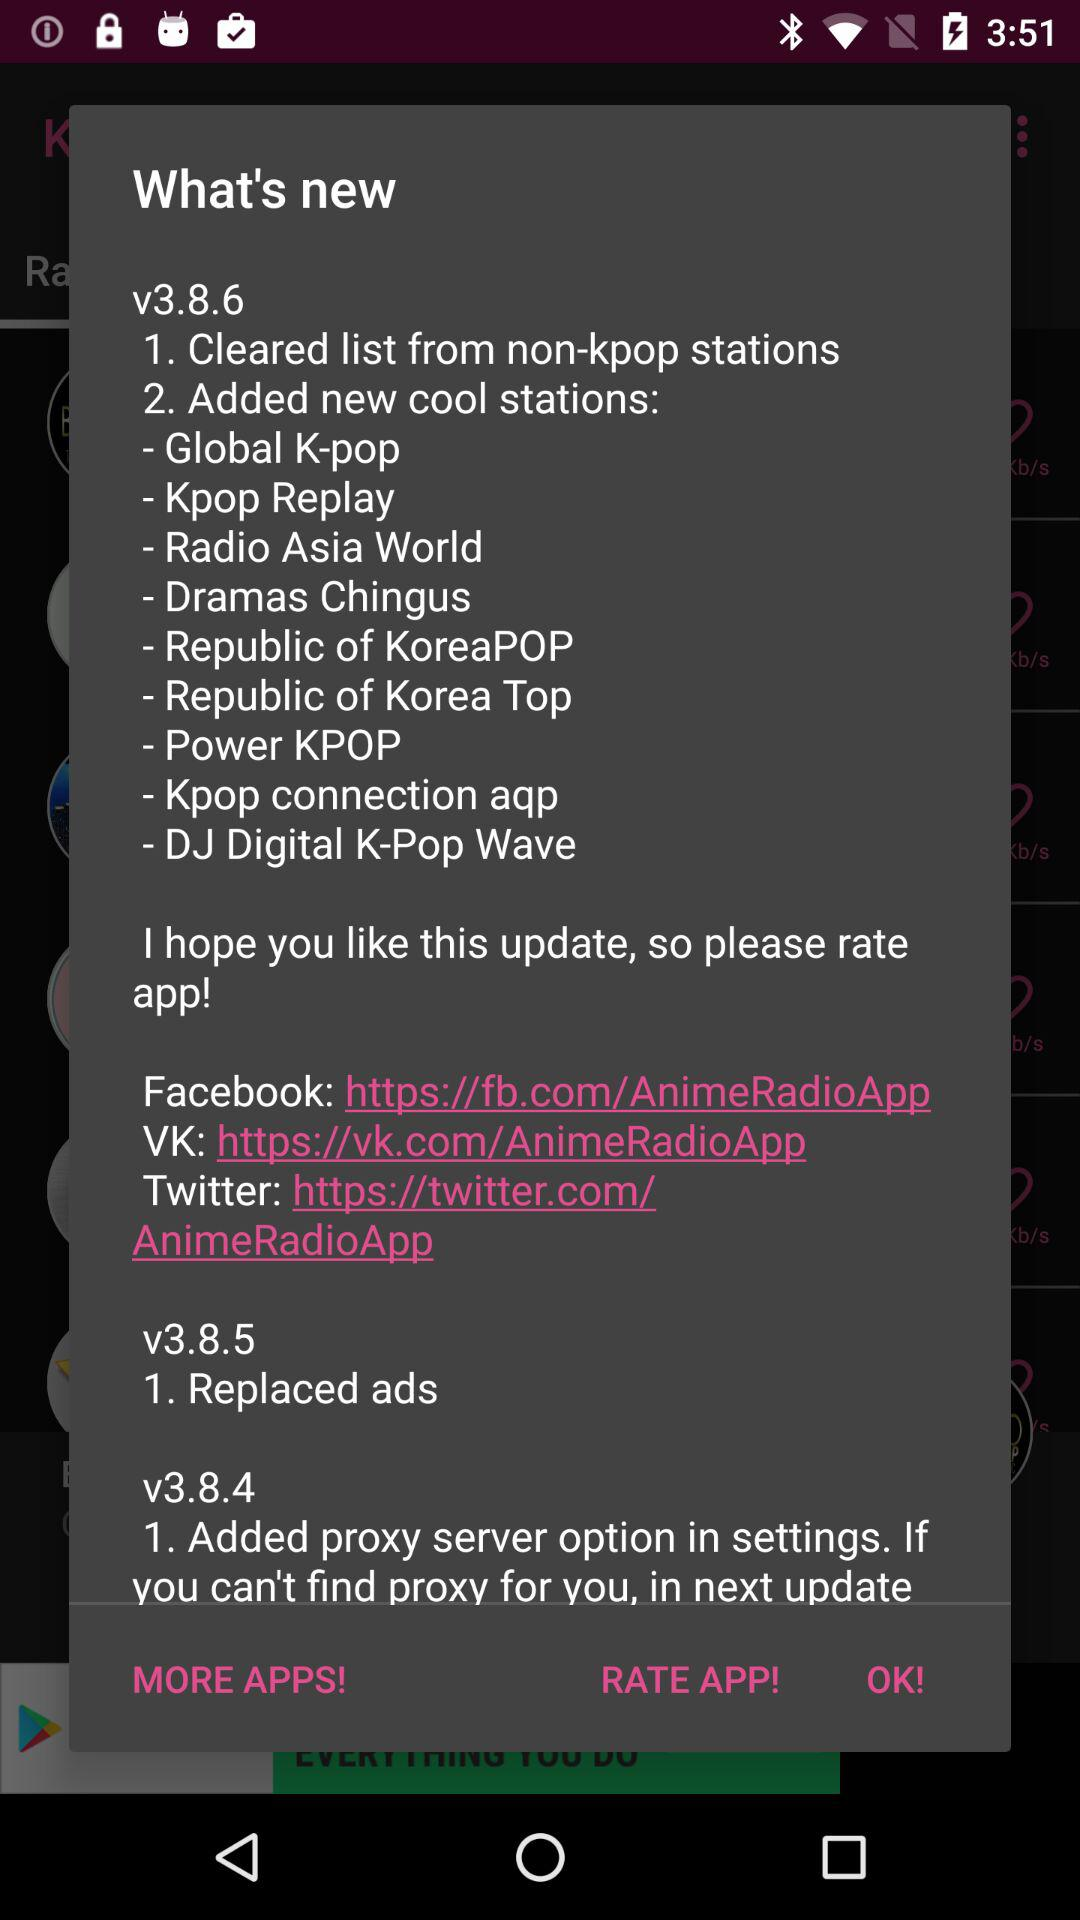What are the new features added in the new version? What are the new features added in version v3.8.6? The new features added in version v3.8.6 are "Cleared list from non-kpop stations" and "Added new cool stations: Global K-pop, Kpop Replay, Radio Asia World, Dramas Chingus, Republic of KoreaPOP, Republic of Korea Top, Power KPOP, Kpop connection aqp and DJ Digital K-Pop Wave". 